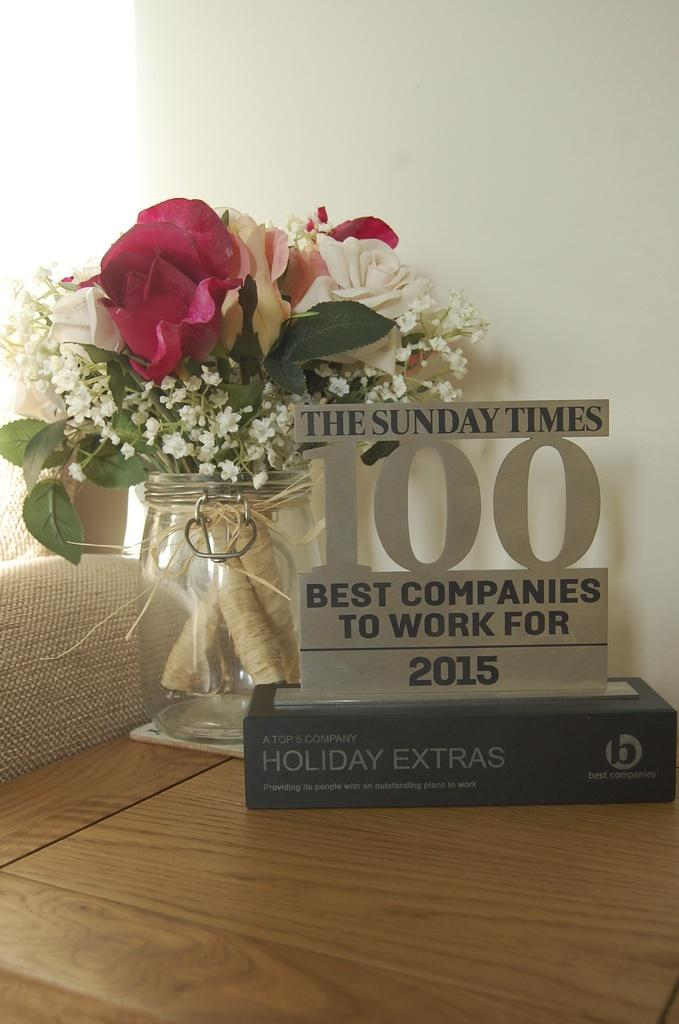What is the main object in the image? There is a table in the image. What is placed on the table? There is an award and a jar with flowers and leaves on the table. What can be seen in the background of the image? There is a white wall in the background of the image. How many rabbits are sitting on the table in the image? There are no rabbits present in the image. What type of steel is used to construct the award in the image? The image does not provide information about the type of steel used to construct the award, nor is there any steel visible in the image. 